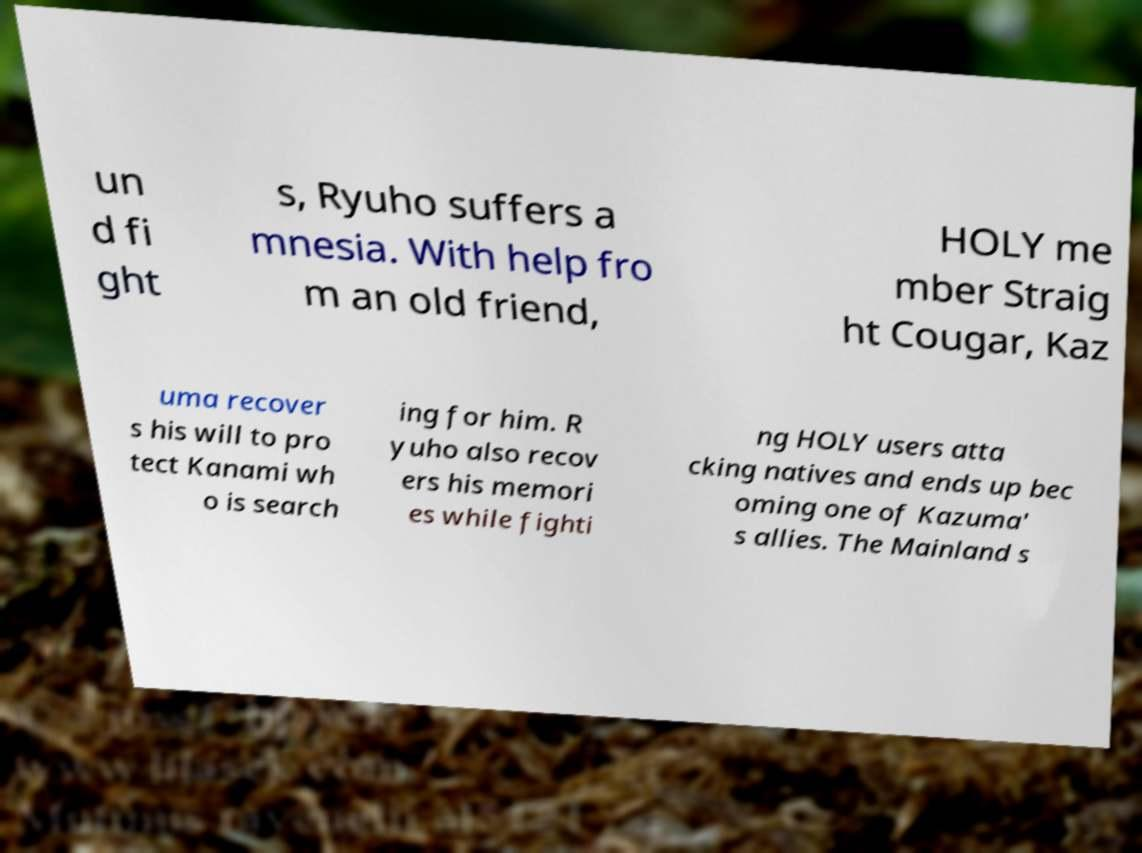For documentation purposes, I need the text within this image transcribed. Could you provide that? un d fi ght s, Ryuho suffers a mnesia. With help fro m an old friend, HOLY me mber Straig ht Cougar, Kaz uma recover s his will to pro tect Kanami wh o is search ing for him. R yuho also recov ers his memori es while fighti ng HOLY users atta cking natives and ends up bec oming one of Kazuma' s allies. The Mainland s 